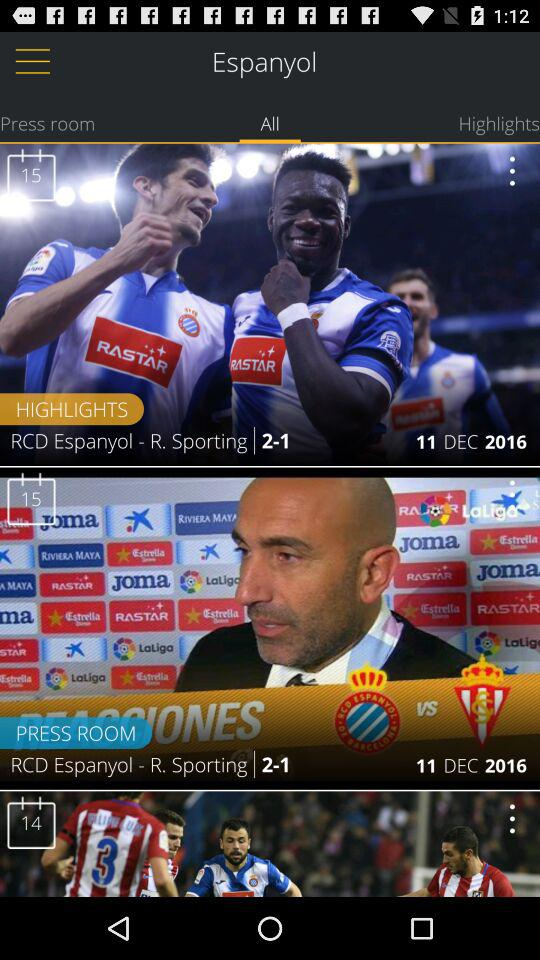On what day was the press room released? The press room was released on December 11, 2016. 